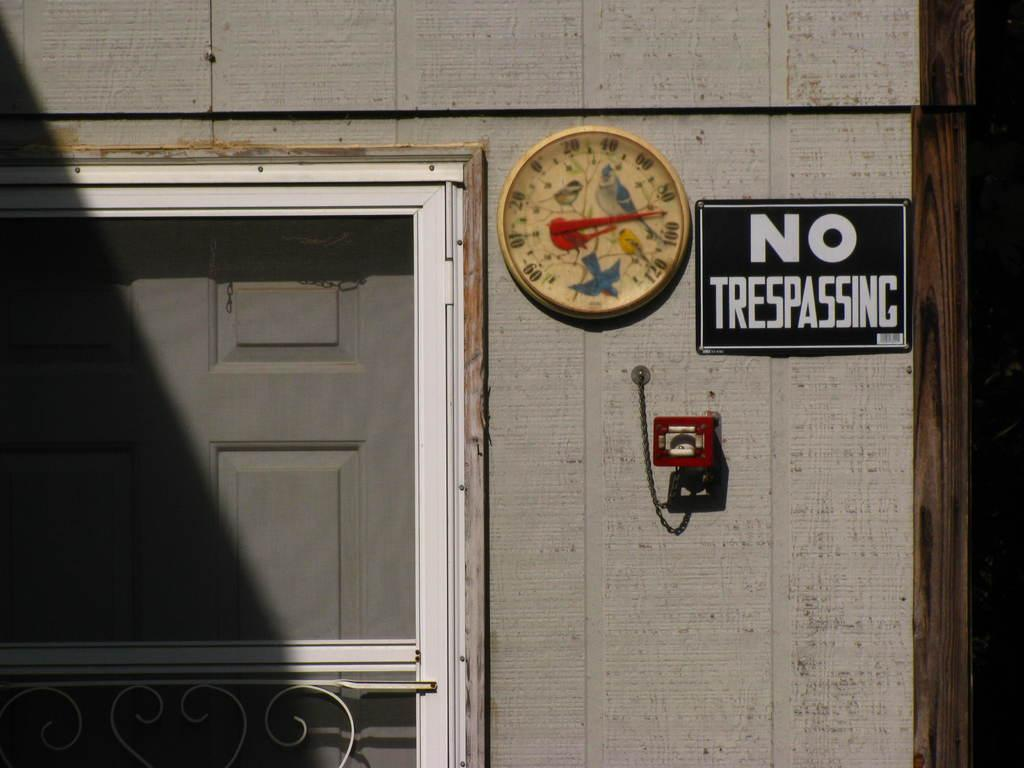What type of structure is visible in the image? There is a building in the image. Where is the door located on the building? The door is on the left side of the building. What feature is present on the left side of the building? There is a railing on the left side of the building. What can be seen in the center of the image? There is a clock in the center of the image. What is on the right side of the image? There is a board and some objects on the right side of the image. Where is the faucet located in the image? There is no faucet present in the image. What type of beast can be seen roaming around the building in the image? There is no beast present in the image. 